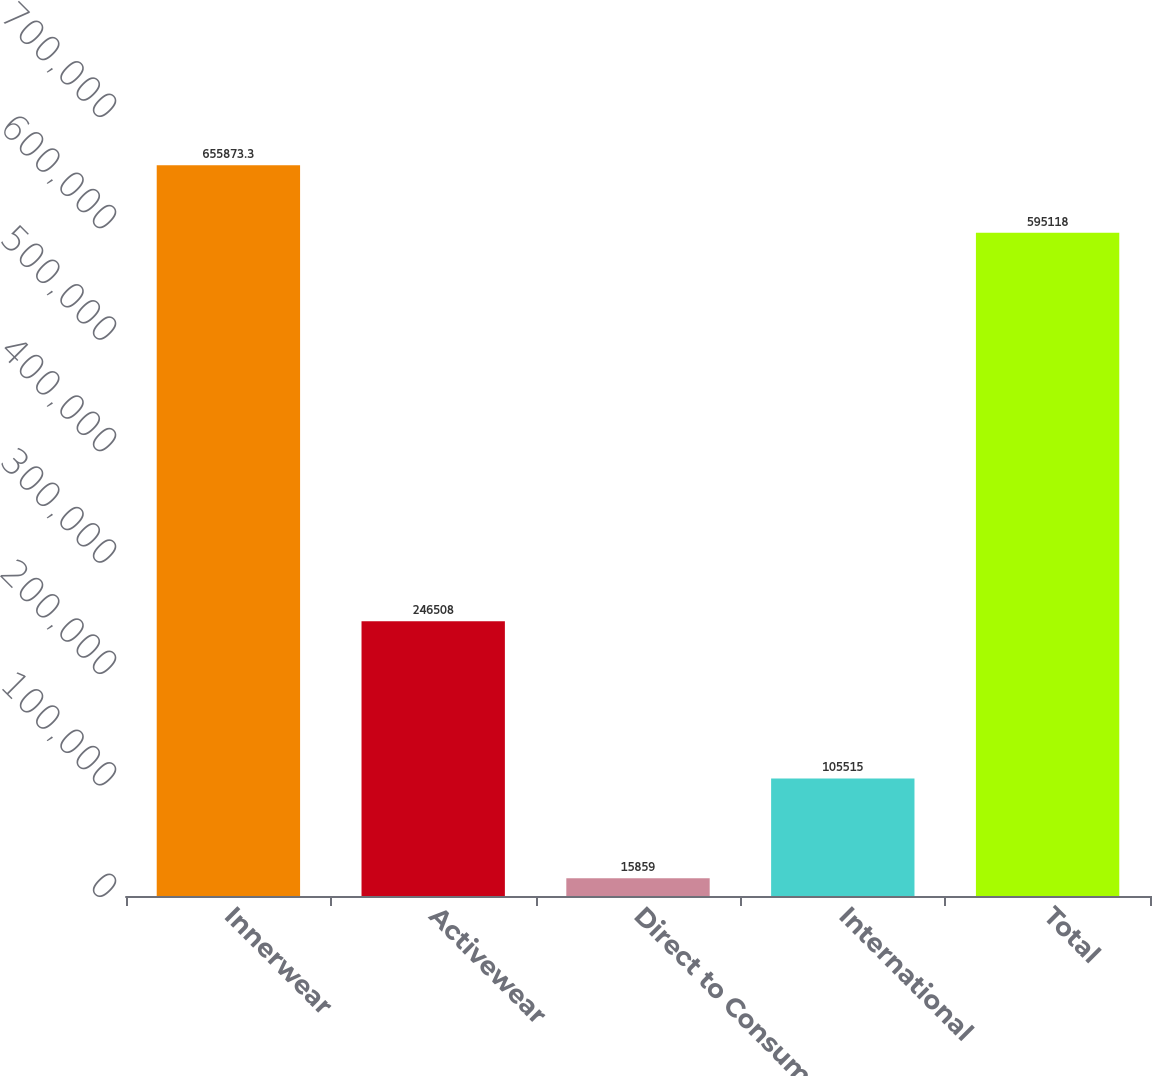Convert chart to OTSL. <chart><loc_0><loc_0><loc_500><loc_500><bar_chart><fcel>Innerwear<fcel>Activewear<fcel>Direct to Consumer<fcel>International<fcel>Total<nl><fcel>655873<fcel>246508<fcel>15859<fcel>105515<fcel>595118<nl></chart> 